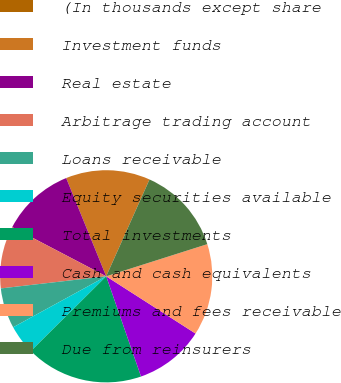<chart> <loc_0><loc_0><loc_500><loc_500><pie_chart><fcel>(In thousands except share<fcel>Investment funds<fcel>Real estate<fcel>Arbitrage trading account<fcel>Loans receivable<fcel>Equity securities available<fcel>Total investments<fcel>Cash and cash equivalents<fcel>Premiums and fees receivable<fcel>Due from reinsurers<nl><fcel>0.0%<fcel>12.85%<fcel>11.17%<fcel>9.5%<fcel>6.15%<fcel>4.47%<fcel>17.88%<fcel>10.61%<fcel>13.97%<fcel>13.41%<nl></chart> 